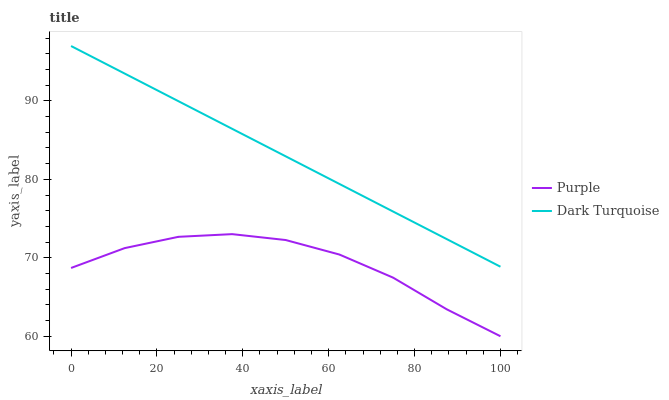Does Purple have the minimum area under the curve?
Answer yes or no. Yes. Does Dark Turquoise have the maximum area under the curve?
Answer yes or no. Yes. Does Dark Turquoise have the minimum area under the curve?
Answer yes or no. No. Is Dark Turquoise the smoothest?
Answer yes or no. Yes. Is Purple the roughest?
Answer yes or no. Yes. Is Dark Turquoise the roughest?
Answer yes or no. No. Does Purple have the lowest value?
Answer yes or no. Yes. Does Dark Turquoise have the lowest value?
Answer yes or no. No. Does Dark Turquoise have the highest value?
Answer yes or no. Yes. Is Purple less than Dark Turquoise?
Answer yes or no. Yes. Is Dark Turquoise greater than Purple?
Answer yes or no. Yes. Does Purple intersect Dark Turquoise?
Answer yes or no. No. 